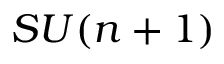<formula> <loc_0><loc_0><loc_500><loc_500>S U ( n + 1 )</formula> 